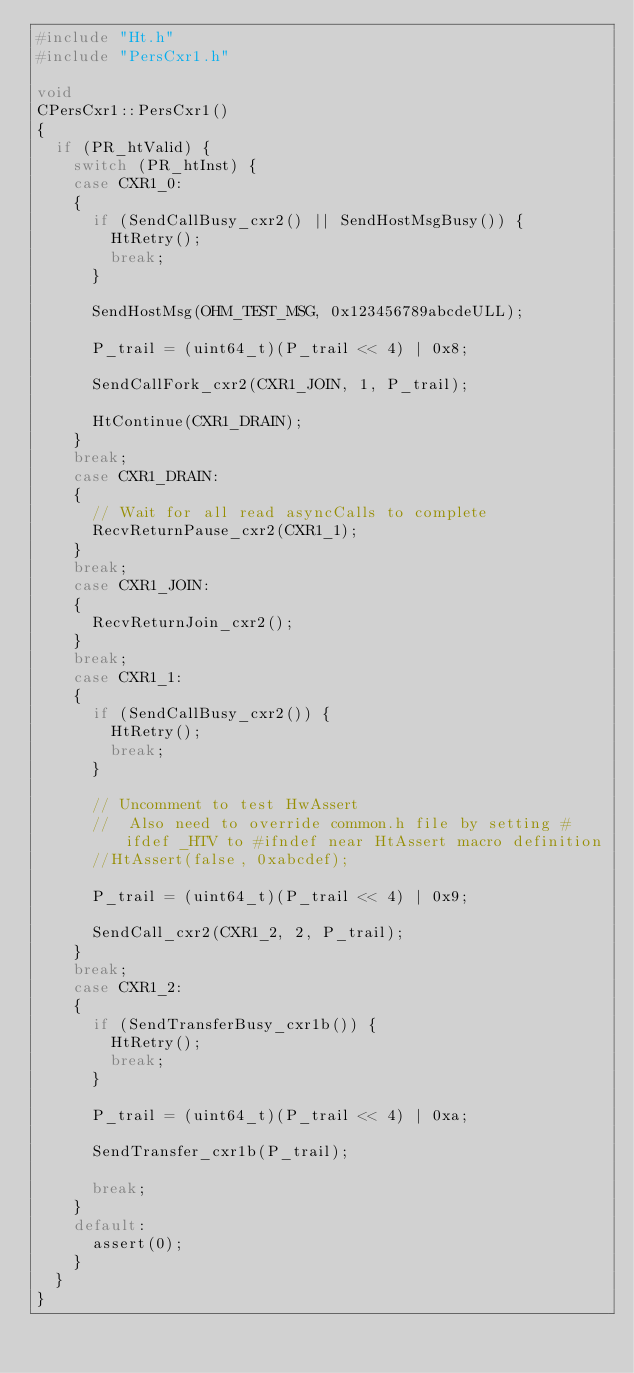<code> <loc_0><loc_0><loc_500><loc_500><_C++_>#include "Ht.h"
#include "PersCxr1.h"

void
CPersCxr1::PersCxr1()
{
	if (PR_htValid) {
		switch (PR_htInst) {
		case CXR1_0:
		{
			if (SendCallBusy_cxr2() || SendHostMsgBusy()) {
				HtRetry();
				break;
			}

			SendHostMsg(OHM_TEST_MSG, 0x123456789abcdeULL);

			P_trail = (uint64_t)(P_trail << 4) | 0x8;

			SendCallFork_cxr2(CXR1_JOIN, 1, P_trail);

			HtContinue(CXR1_DRAIN);
		}
		break;
		case CXR1_DRAIN:
		{
			// Wait for all read asyncCalls to complete
			RecvReturnPause_cxr2(CXR1_1);
		}
		break;
		case CXR1_JOIN:
		{
			RecvReturnJoin_cxr2();
		}
		break;
		case CXR1_1:
		{
			if (SendCallBusy_cxr2()) {
				HtRetry();
				break;
			}

			// Uncomment to test HwAssert
			//  Also need to override common.h file by setting #ifdef _HTV to #ifndef near HtAssert macro definition
			//HtAssert(false, 0xabcdef);

			P_trail = (uint64_t)(P_trail << 4) | 0x9;

			SendCall_cxr2(CXR1_2, 2, P_trail);
		}
		break;
		case CXR1_2:
		{
			if (SendTransferBusy_cxr1b()) {
				HtRetry();
				break;
			}

			P_trail = (uint64_t)(P_trail << 4) | 0xa;

			SendTransfer_cxr1b(P_trail);

			break;
		}
		default:
			assert(0);
		}
	}
}
</code> 